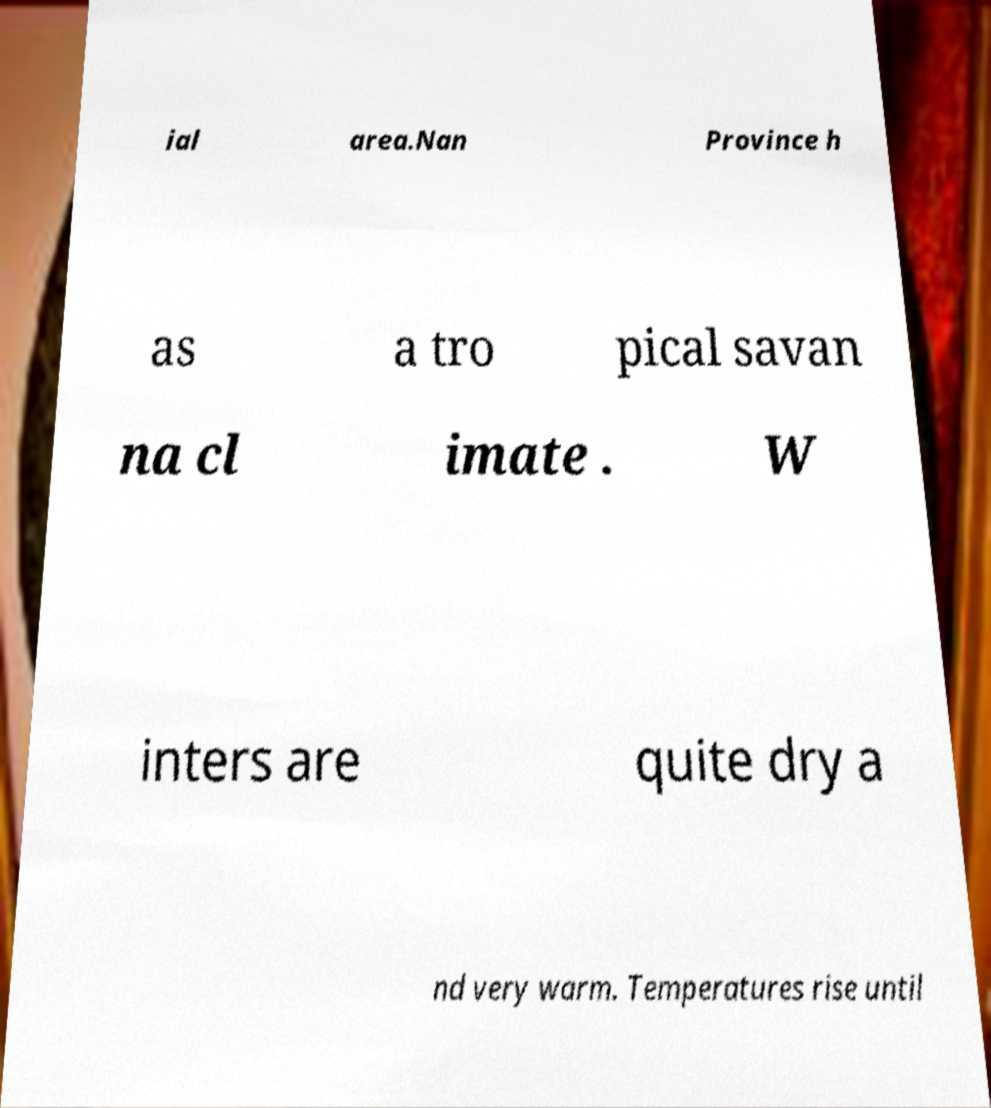Please read and relay the text visible in this image. What does it say? ial area.Nan Province h as a tro pical savan na cl imate . W inters are quite dry a nd very warm. Temperatures rise until 